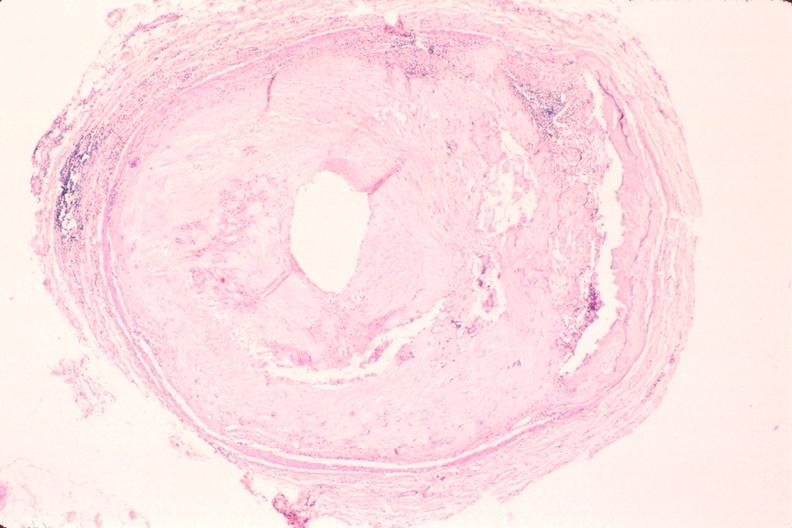s pus in test tube present?
Answer the question using a single word or phrase. No 